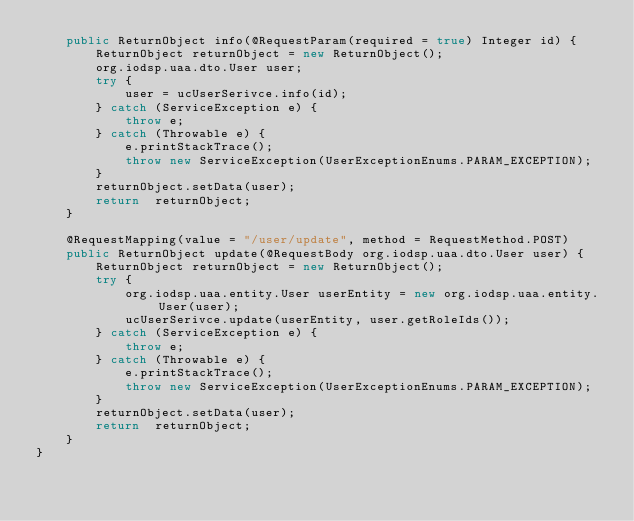<code> <loc_0><loc_0><loc_500><loc_500><_Java_>    public ReturnObject info(@RequestParam(required = true) Integer id) {
        ReturnObject returnObject = new ReturnObject();
        org.iodsp.uaa.dto.User user;
        try {
            user = ucUserSerivce.info(id);
        } catch (ServiceException e) {
            throw e;
        } catch (Throwable e) {
            e.printStackTrace();
            throw new ServiceException(UserExceptionEnums.PARAM_EXCEPTION);
        }
        returnObject.setData(user);
        return  returnObject;
    }

    @RequestMapping(value = "/user/update", method = RequestMethod.POST)
    public ReturnObject update(@RequestBody org.iodsp.uaa.dto.User user) {
        ReturnObject returnObject = new ReturnObject();
        try {
            org.iodsp.uaa.entity.User userEntity = new org.iodsp.uaa.entity.User(user);
            ucUserSerivce.update(userEntity, user.getRoleIds());
        } catch (ServiceException e) {
            throw e;
        } catch (Throwable e) {
            e.printStackTrace();
            throw new ServiceException(UserExceptionEnums.PARAM_EXCEPTION);
        }
        returnObject.setData(user);
        return  returnObject;
    }
}
</code> 